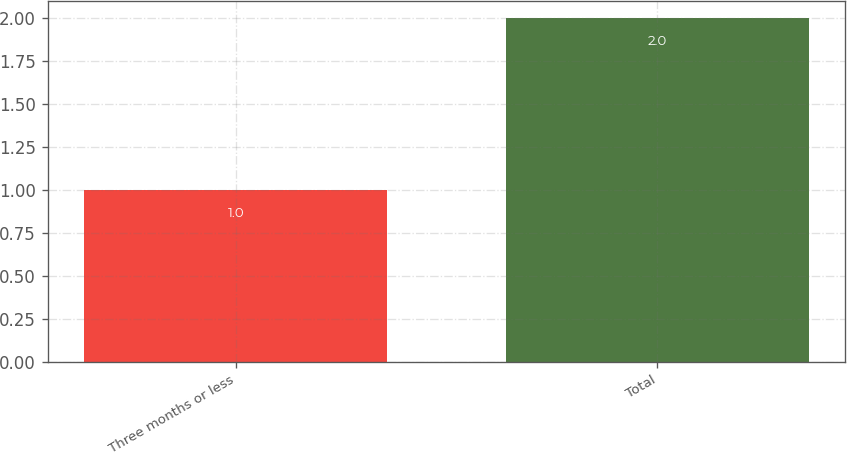Convert chart to OTSL. <chart><loc_0><loc_0><loc_500><loc_500><bar_chart><fcel>Three months or less<fcel>Total<nl><fcel>1<fcel>2<nl></chart> 